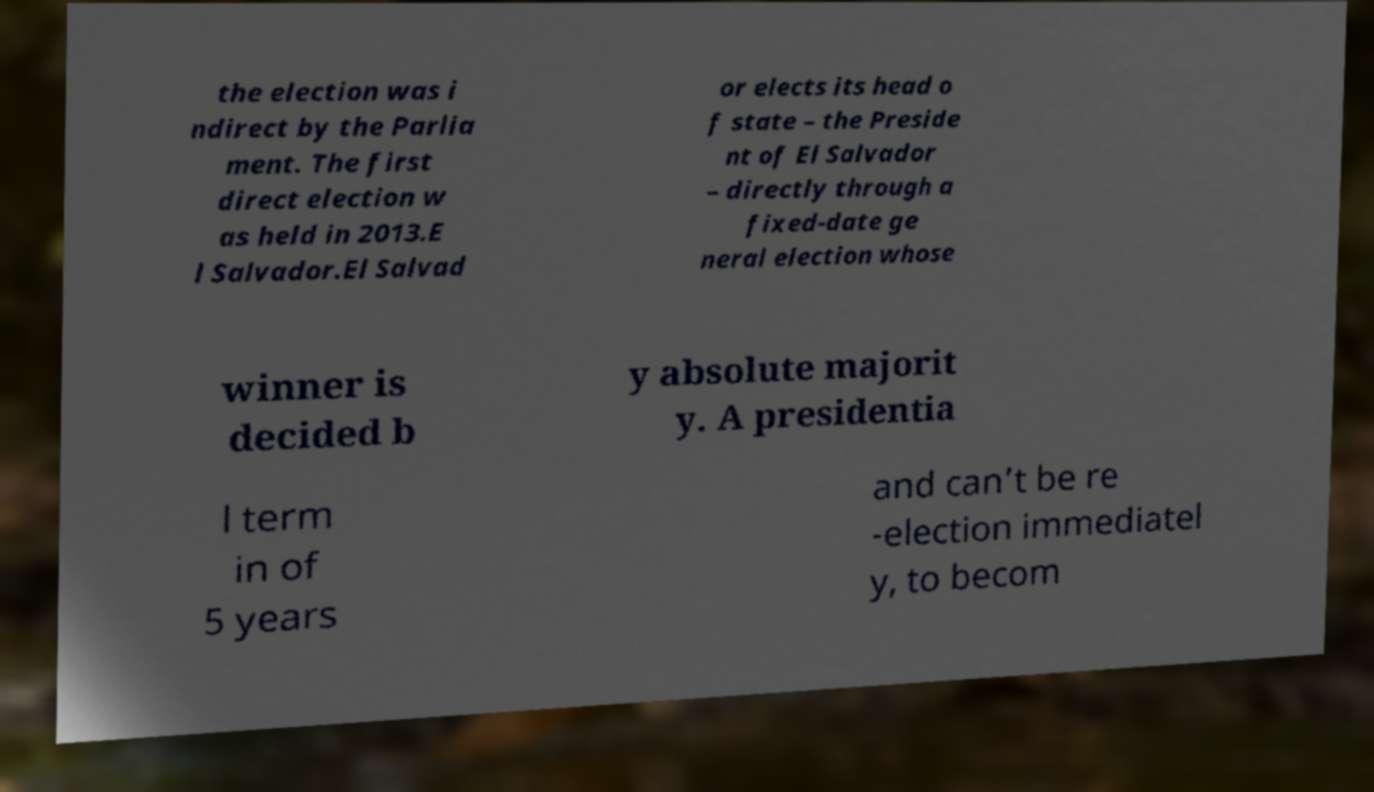I need the written content from this picture converted into text. Can you do that? the election was i ndirect by the Parlia ment. The first direct election w as held in 2013.E l Salvador.El Salvad or elects its head o f state – the Preside nt of El Salvador – directly through a fixed-date ge neral election whose winner is decided b y absolute majorit y. A presidentia l term in of 5 years and can’t be re -election immediatel y, to becom 